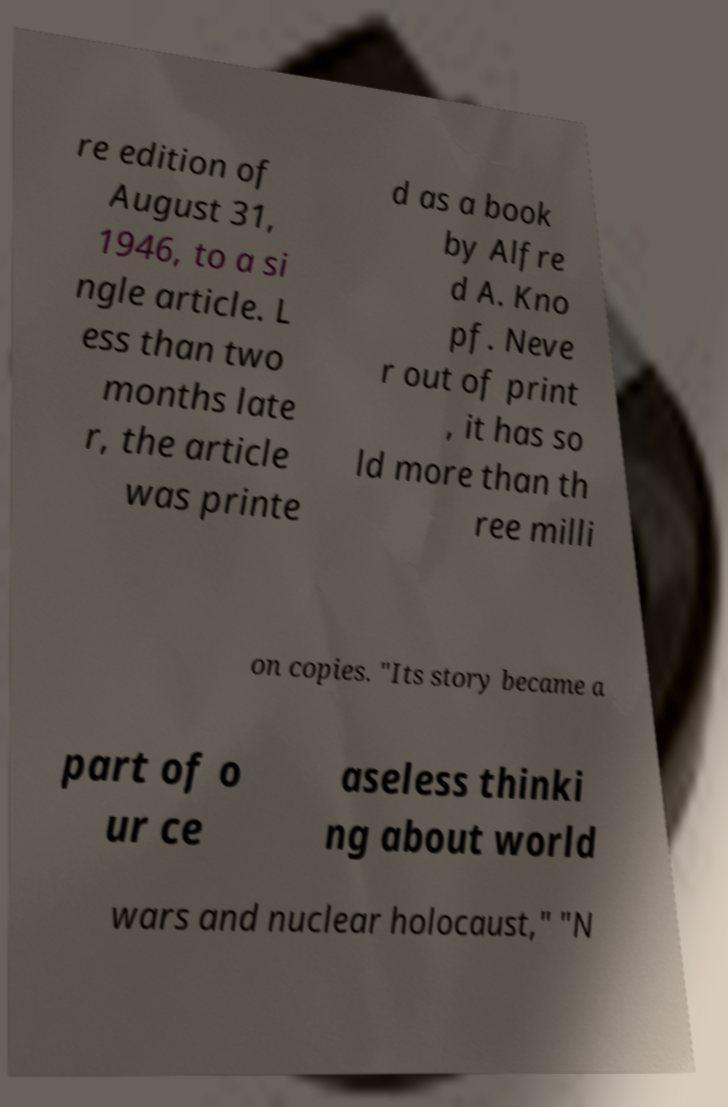I need the written content from this picture converted into text. Can you do that? re edition of August 31, 1946, to a si ngle article. L ess than two months late r, the article was printe d as a book by Alfre d A. Kno pf. Neve r out of print , it has so ld more than th ree milli on copies. "Its story became a part of o ur ce aseless thinki ng about world wars and nuclear holocaust," "N 